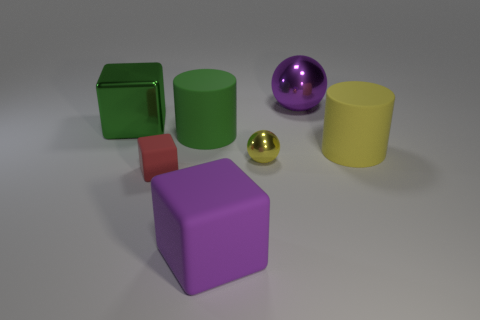How many other things are there of the same color as the large sphere?
Your answer should be compact. 1. Is the number of red matte things that are on the right side of the big shiny ball less than the number of rubber cylinders?
Keep it short and to the point. Yes. How many other things are made of the same material as the tiny yellow thing?
Your answer should be compact. 2. Is the yellow metallic thing the same size as the red matte block?
Keep it short and to the point. Yes. How many things are objects to the left of the green cylinder or yellow spheres?
Provide a short and direct response. 3. What material is the yellow thing on the right side of the purple object behind the green shiny thing?
Provide a short and direct response. Rubber. Are there any small red rubber objects that have the same shape as the yellow shiny object?
Offer a very short reply. No. There is a purple rubber object; does it have the same size as the metal sphere that is behind the large yellow rubber object?
Keep it short and to the point. Yes. How many things are objects that are right of the big green block or cylinders behind the large yellow rubber cylinder?
Provide a succinct answer. 6. Is the number of large green objects that are left of the green shiny cube greater than the number of cyan metallic cubes?
Offer a terse response. No. 